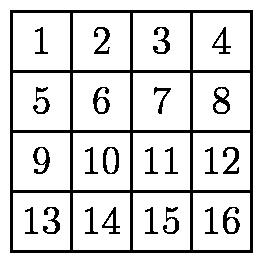The $16$ squares on a piece of paper are numbered as shown in the diagram. While lying on a table, the paper is folded in half four times in the following sequence: fold the top half over the bottom half, fold the bottom half over the top half, fold the right half over the left half, fold the left half over the right half. Which numbered square is on top after step $4$? After closely analyzing the sequence of folds given, starting with square number 9 positioned in the first column of the third row, we follow each fold. After two vertical folds and two horizontal folds, square number 9 ends up in the uppermost left position — on top when the final fold is completed. This analysis assumes an accurate and ideal folding where each half lines up perfectly. It is important to visualize the folds step by step or experiment physically with similar folding actions to comprehend the transitions fully. 